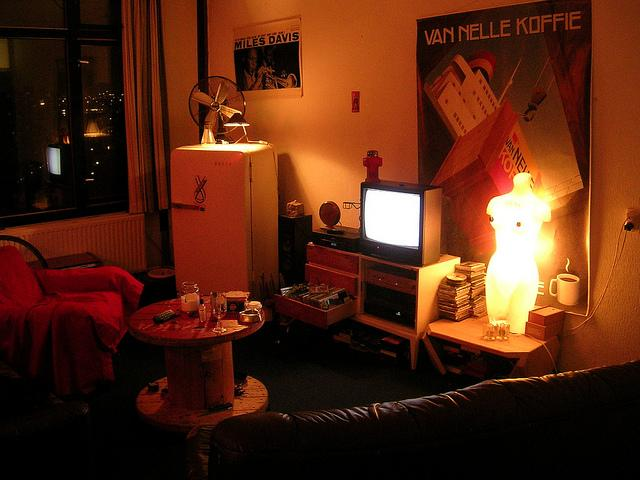The last word on the poster on the right is most likely pronounced similarly to what? Please explain your reasoning. coffee. A poster has a work that phonetically matches the word coffee. 